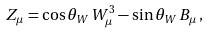<formula> <loc_0><loc_0><loc_500><loc_500>Z _ { \mu } = \cos \theta _ { W } \, W ^ { 3 } _ { \mu } - \sin \theta _ { W } \, B _ { \mu } \, ,</formula> 